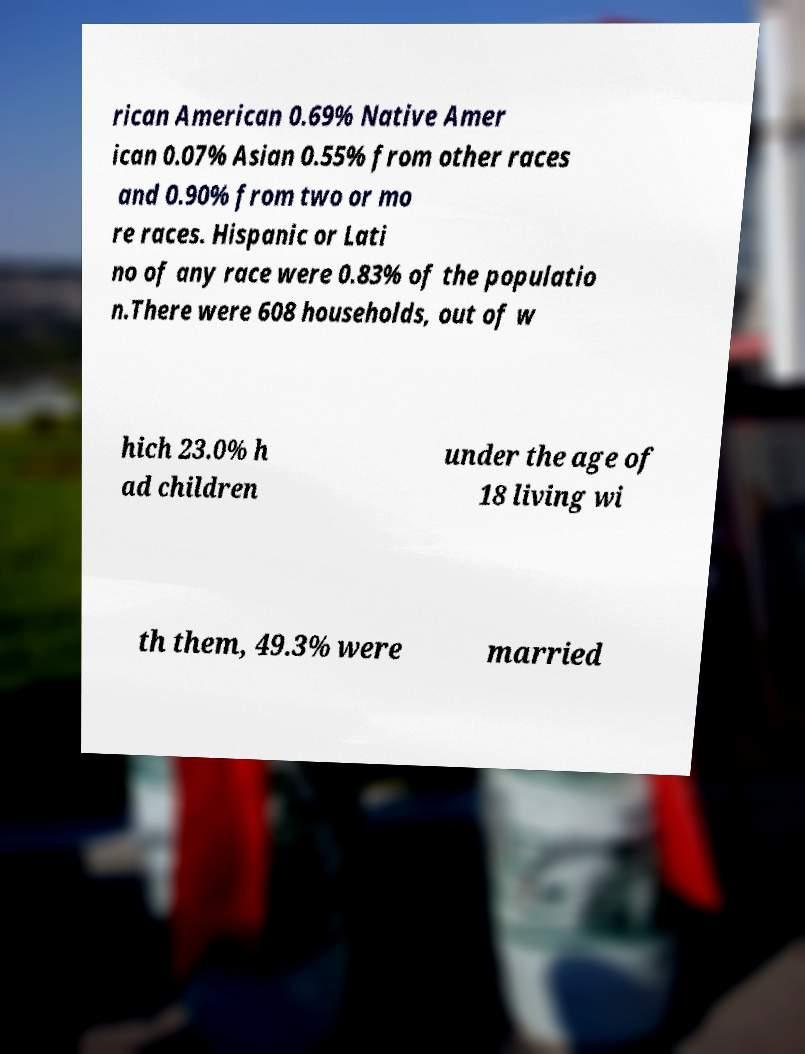Can you accurately transcribe the text from the provided image for me? rican American 0.69% Native Amer ican 0.07% Asian 0.55% from other races and 0.90% from two or mo re races. Hispanic or Lati no of any race were 0.83% of the populatio n.There were 608 households, out of w hich 23.0% h ad children under the age of 18 living wi th them, 49.3% were married 